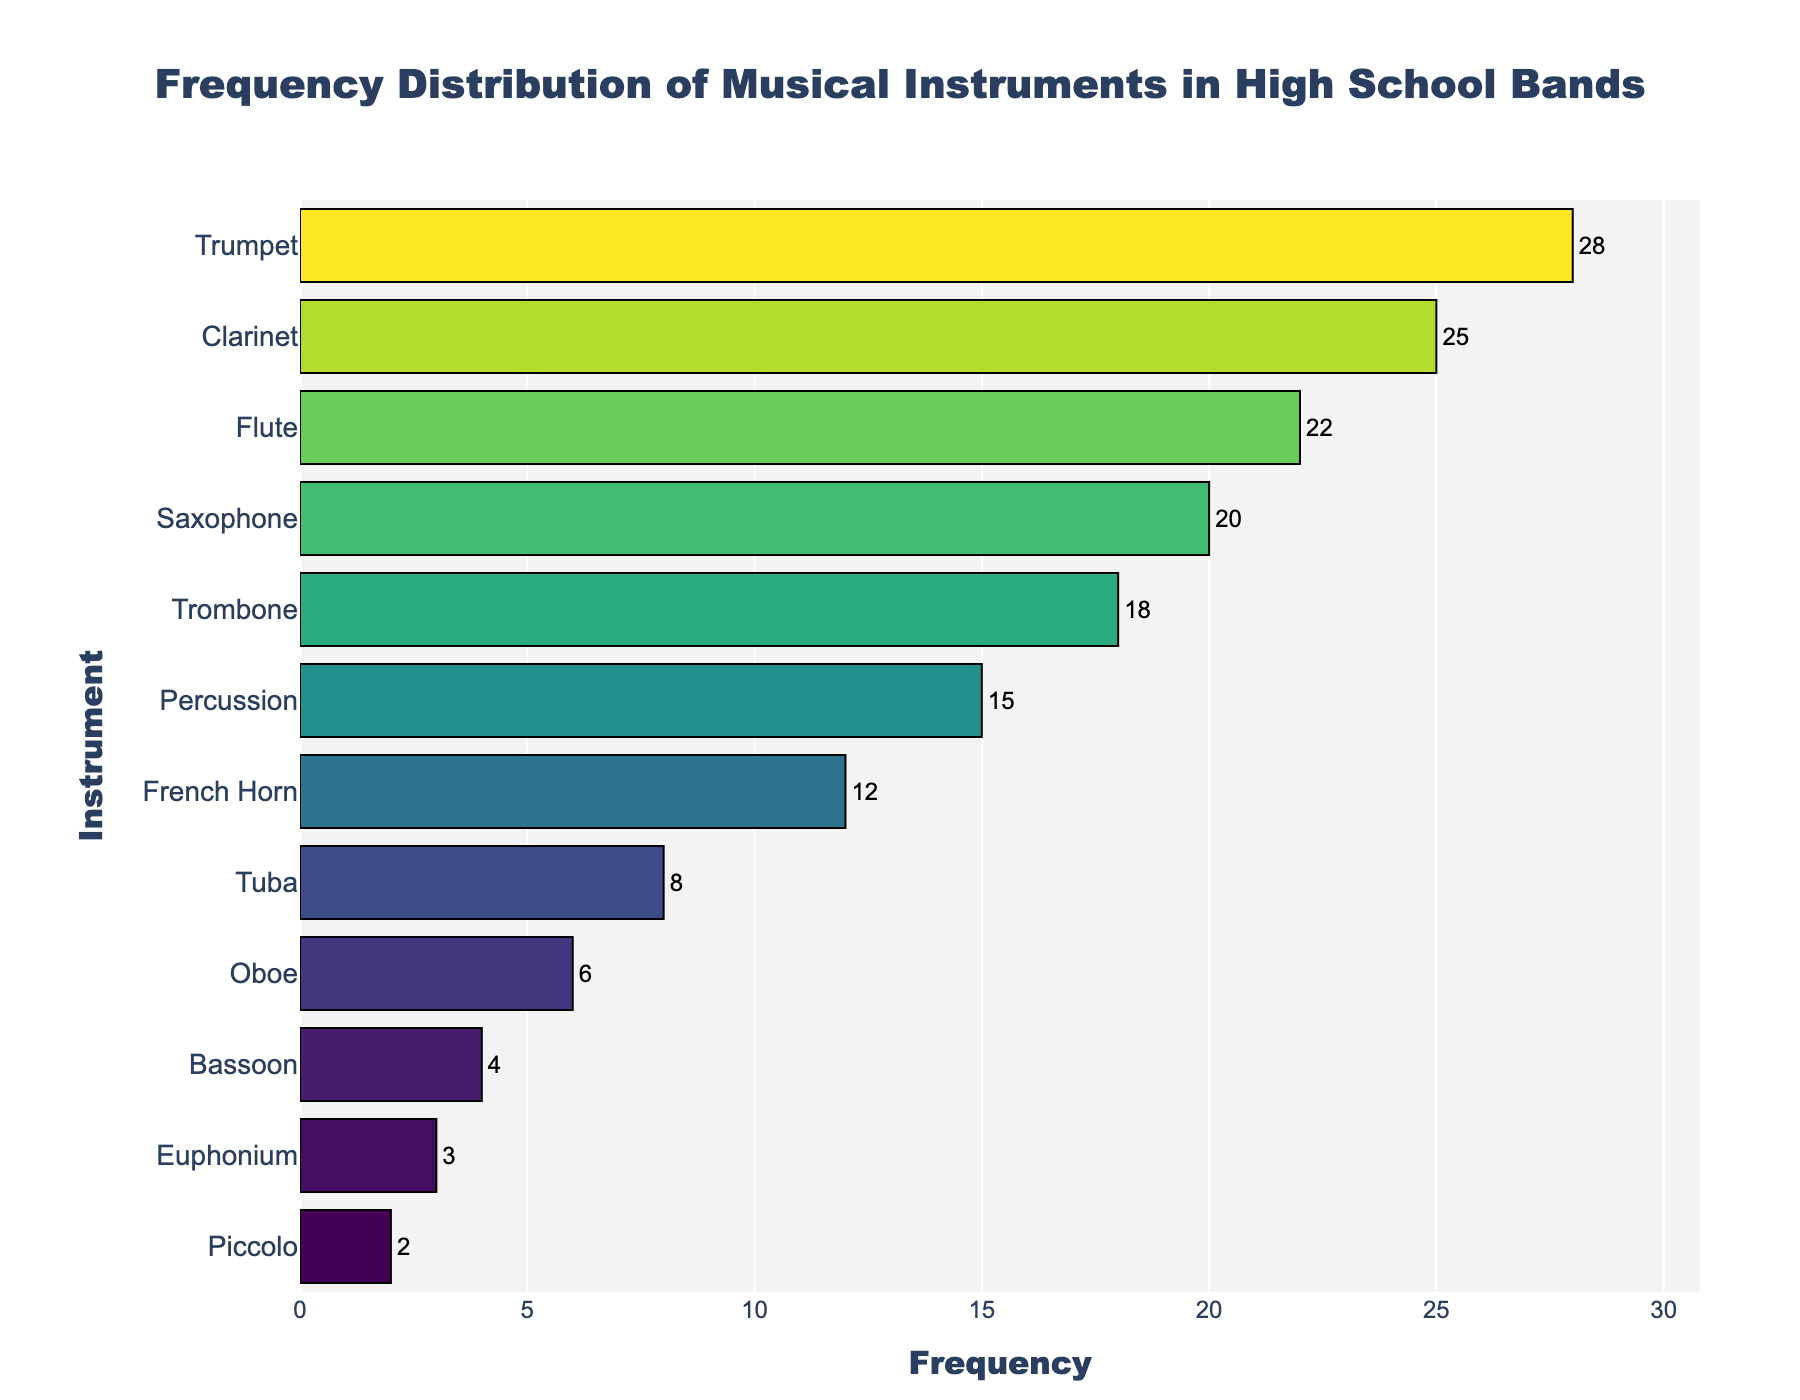What's the most frequent musical instrument in high school bands? The topmost bar in the plot represents the instrument with the highest frequency. It shows that the Trumpet has the longest bar.
Answer: Trumpet Which instrument has the least frequency? The bottommost bar in the plot represents the instrument with the lowest frequency. The Piccolo has the shortest bar.
Answer: Piccolo What is the total frequency of all instruments combined? Sum the frequencies of all instruments: 28 (Trumpet) + 25 (Clarinet) + 22 (Flute) + 20 (Saxophone) + 18 (Trombone) + 15 (Percussion) + 12 (French Horn) + 8 (Tuba) + 6 (Oboe) + 4 (Bassoon) + 3 (Euphonium) + 2 (Piccolo) = 163
Answer: 163 How many instruments have a frequency greater than 20? Count the instruments with a frequency higher than 20 based on the plot bars. Trumpet, Clarinet, and Flute are the ones with frequencies 28, 25, and 22 respectively.
Answer: 3 Which is more frequent in high school bands, Percussion or French Horn? Compare the lengths of the bars for Percussion and French Horn. Percussion has a frequency of 15, whereas French Horn has a frequency of 12.
Answer: Percussion What is the average frequency of the Flute, Saxophone, and Trombone combined? First add the frequencies of the Flute, Saxophone, and Trombone, then divide by 3. (22 + 20 + 18) / 3 = 60 / 3 = 20
Answer: 20 Among the instruments with a frequency less than 10, which one is most frequent? Look at instruments with frequencies lower than 10 and find the highest among them. Tuba has a frequency of 8, which is higher than Oboe (6), Bassoon (4), Euphonium (3), and Piccolo (2).
Answer: Tuba What is the difference in frequency between the Trumpet and the Clarinet? Subtract the frequency of Clarinet from the frequency of Trumpet: 28 - 25 = 3
Answer: 3 Which instrument is in the middle in terms of frequency? There are 12 instruments, so the middle one is the 6th if sorted by frequency. The 6th one is Percussion with a frequency of 15.
Answer: Percussion How does the frequency of the Oboe compare to the Euphonium? Compare the lengths of their bars. Oboe has a frequency of 6 while Euphonium has a frequency of 3. So, the Oboe's frequency is higher.
Answer: Oboe 